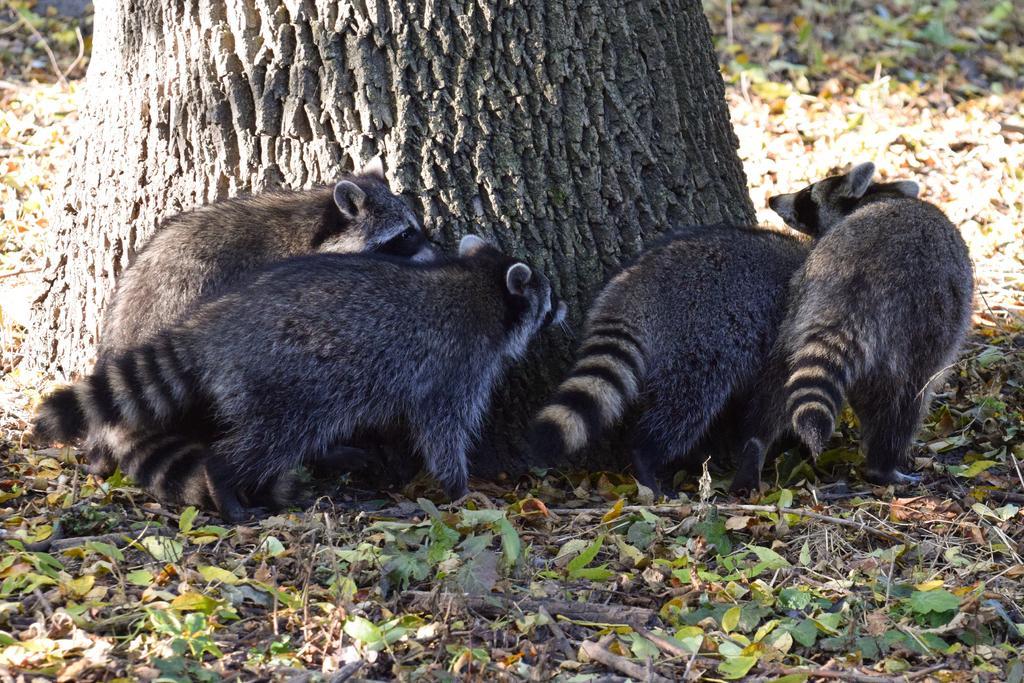Could you give a brief overview of what you see in this image? This image consists of animals walking on the ground. At the bottom, there are dry leaves. In the front, there is a tree. It looks like it is clicked in a forest. 